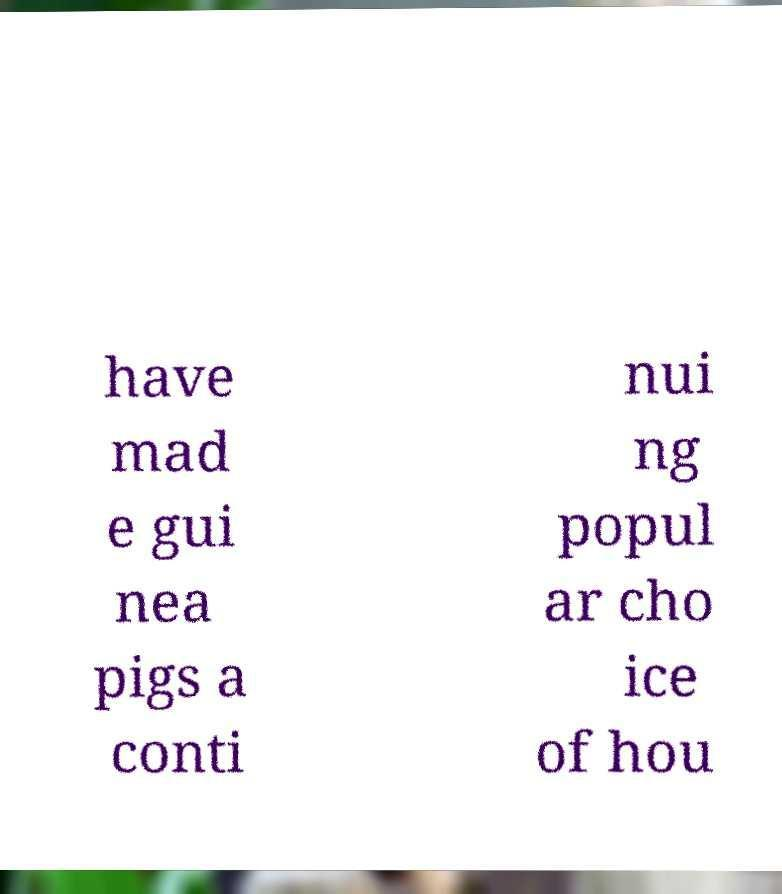What messages or text are displayed in this image? I need them in a readable, typed format. have mad e gui nea pigs a conti nui ng popul ar cho ice of hou 